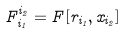Convert formula to latex. <formula><loc_0><loc_0><loc_500><loc_500>F _ { i _ { 1 } } ^ { i _ { 2 } } = F [ r _ { i _ { 1 } } , x _ { i _ { 2 } } ]</formula> 